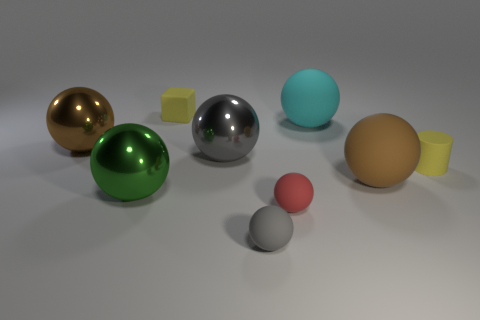There is a object that is the same color as the tiny cylinder; what is it made of?
Make the answer very short. Rubber. Is there a big sphere that has the same color as the cube?
Keep it short and to the point. No. Are the small cylinder and the brown thing that is left of the green metallic sphere made of the same material?
Provide a short and direct response. No. There is a small yellow object that is on the left side of the cyan sphere; are there any small matte objects in front of it?
Make the answer very short. Yes. What is the color of the big object that is to the left of the cyan rubber sphere and to the right of the green metal ball?
Your answer should be very brief. Gray. The yellow cylinder is what size?
Offer a terse response. Small. How many gray metal cylinders are the same size as the red ball?
Offer a terse response. 0. Do the big brown ball to the right of the gray metal ball and the big brown ball to the left of the tiny red matte thing have the same material?
Make the answer very short. No. There is a gray ball right of the large metal thing to the right of the tiny rubber cube; what is its material?
Provide a short and direct response. Rubber. What material is the brown sphere that is in front of the tiny yellow cylinder?
Make the answer very short. Rubber. 